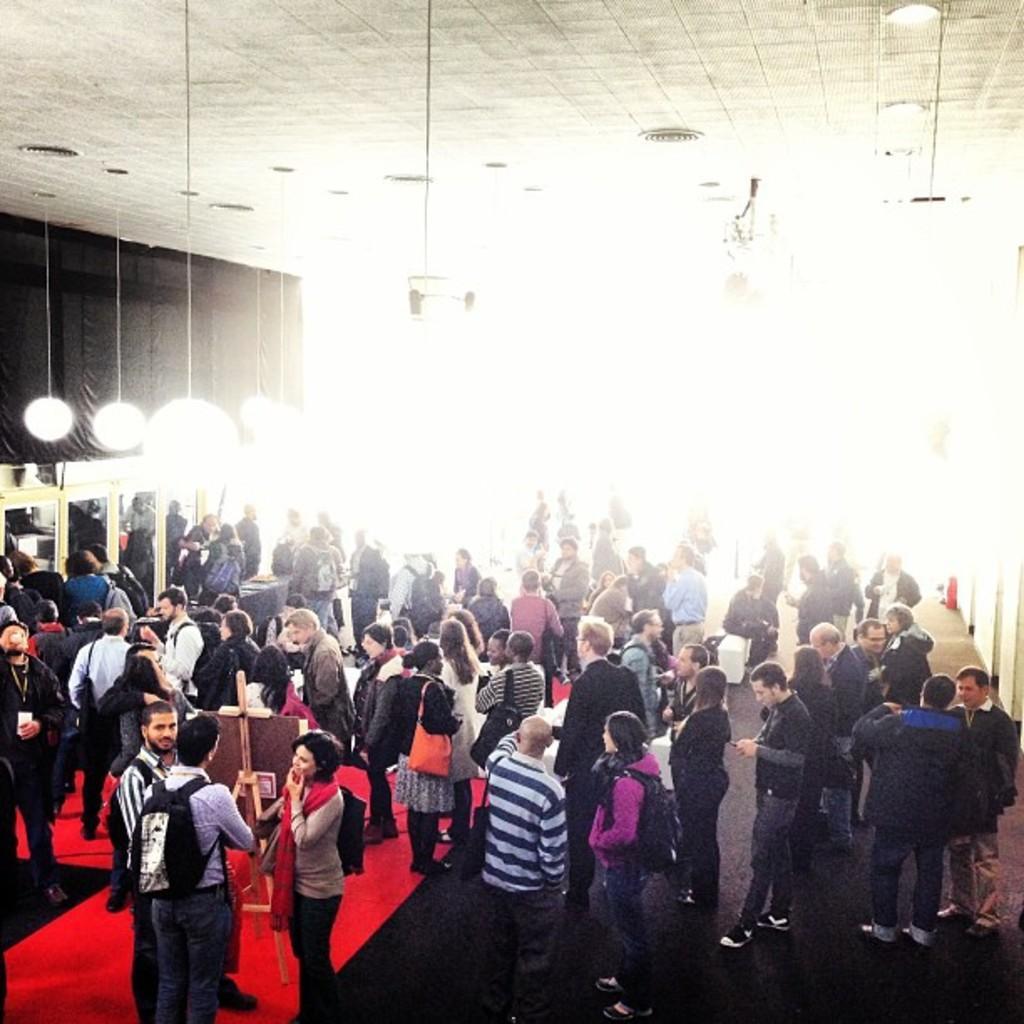In one or two sentences, can you explain what this image depicts? In the picture I can see a group of people are standing on the floor. Some of them carrying bags. In the background I can see lights on the ceiling, wall and some other objects. 